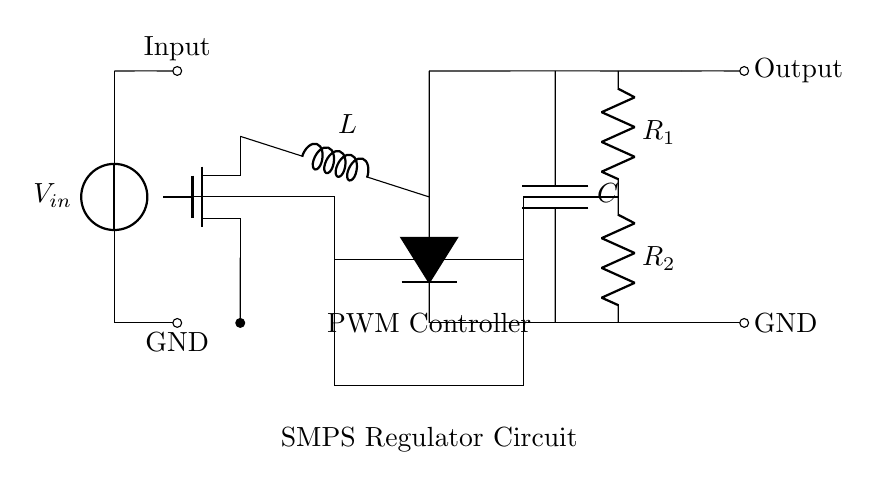What is the input voltage of the circuit? The input voltage is represented by the voltage source labeled V_in in the circuit diagram, located at the top left of the diagram.
Answer: V_in What type of controller is used in this circuit? The circuit features a PWM Controller, indicated by the rectangle labeled 'PWM Controller' in the diagram, which is positioned next to the MOSFET.
Answer: PWM Controller What is the function of the inductor in this circuit? The inductor, labeled L, is meant to store energy and smooth out the current in the switched-mode power supply, as shown connecting the MOSFET and the capacitor.
Answer: Energy storage What are the two feedback resistors in the circuit? The resistors labeled R_1 and R_2 are part of the feedback mechanism, crucial for regulating output voltage. R_1 is connected from a higher voltage node to a mid-point, while R_2 goes to ground.
Answer: R_1 and R_2 How many capacitors are in this circuit? The circuit contains one capacitor, indicated by the label C, which connects the output side to ground in order to filter the output voltage.
Answer: One What activates the MOSFET in this design? The gate of the MOSFET is activated by a PWM signal, which comes from the PWM controller as specified in the diagram, allowing control over the MOSFET’s switching behavior.
Answer: PWM signal What is the role of the diode in this SMPS circuit? The diode, labeled D, provides a path for current during the off periods of the MOSFET, facilitating energy recovery and preventing reverse current flow.
Answer: Current path 